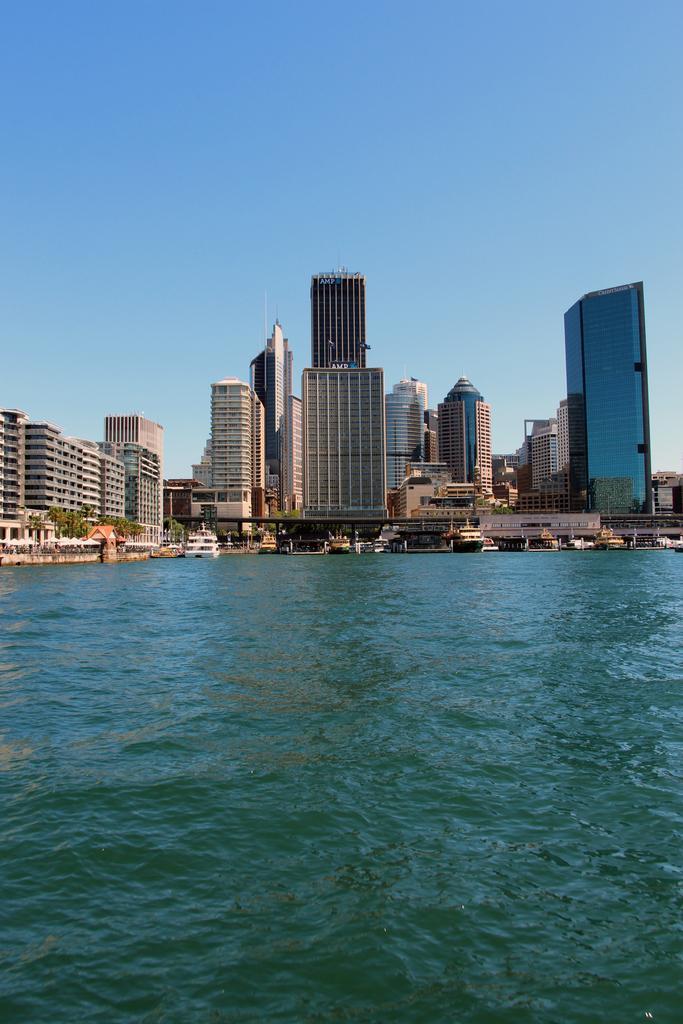How would you summarize this image in a sentence or two? In this image there is a river on that river there are boats, in the background there are buildings and the sky. 